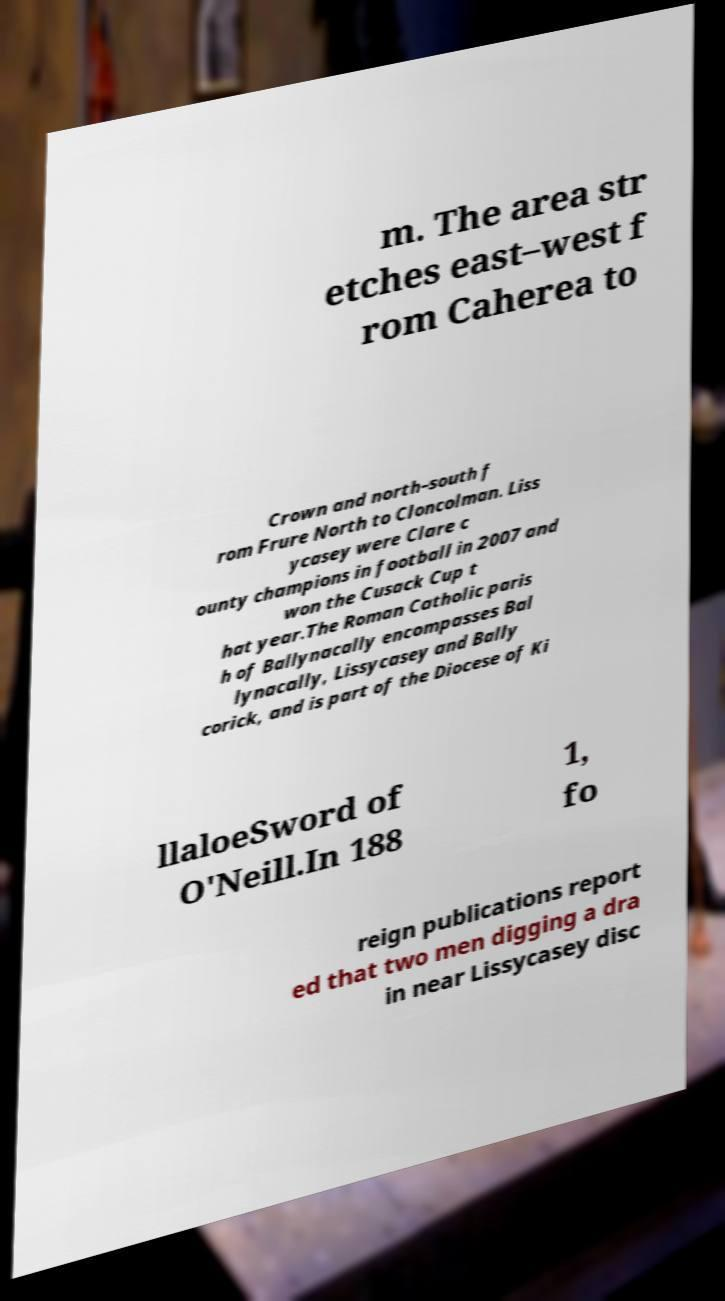Could you extract and type out the text from this image? m. The area str etches east–west f rom Caherea to Crown and north–south f rom Frure North to Cloncolman. Liss ycasey were Clare c ounty champions in football in 2007 and won the Cusack Cup t hat year.The Roman Catholic paris h of Ballynacally encompasses Bal lynacally, Lissycasey and Bally corick, and is part of the Diocese of Ki llaloeSword of O'Neill.In 188 1, fo reign publications report ed that two men digging a dra in near Lissycasey disc 